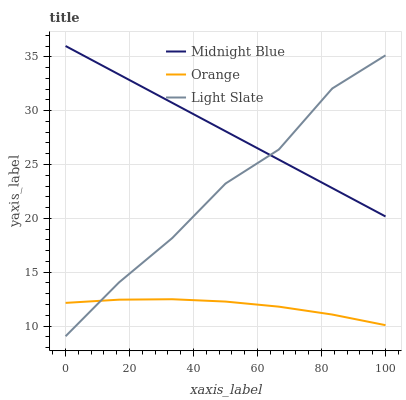Does Orange have the minimum area under the curve?
Answer yes or no. Yes. Does Midnight Blue have the maximum area under the curve?
Answer yes or no. Yes. Does Light Slate have the minimum area under the curve?
Answer yes or no. No. Does Light Slate have the maximum area under the curve?
Answer yes or no. No. Is Midnight Blue the smoothest?
Answer yes or no. Yes. Is Light Slate the roughest?
Answer yes or no. Yes. Is Light Slate the smoothest?
Answer yes or no. No. Is Midnight Blue the roughest?
Answer yes or no. No. Does Light Slate have the lowest value?
Answer yes or no. Yes. Does Midnight Blue have the lowest value?
Answer yes or no. No. Does Midnight Blue have the highest value?
Answer yes or no. Yes. Does Light Slate have the highest value?
Answer yes or no. No. Is Orange less than Midnight Blue?
Answer yes or no. Yes. Is Midnight Blue greater than Orange?
Answer yes or no. Yes. Does Orange intersect Light Slate?
Answer yes or no. Yes. Is Orange less than Light Slate?
Answer yes or no. No. Is Orange greater than Light Slate?
Answer yes or no. No. Does Orange intersect Midnight Blue?
Answer yes or no. No. 